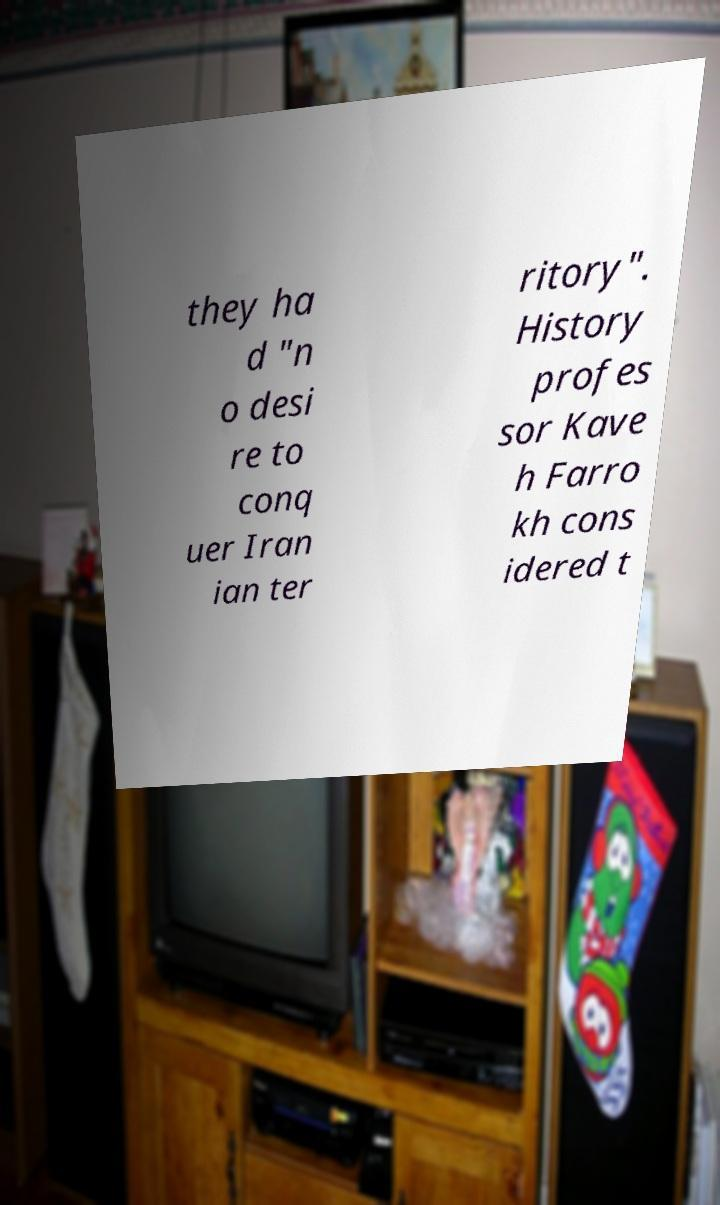There's text embedded in this image that I need extracted. Can you transcribe it verbatim? they ha d "n o desi re to conq uer Iran ian ter ritory". History profes sor Kave h Farro kh cons idered t 